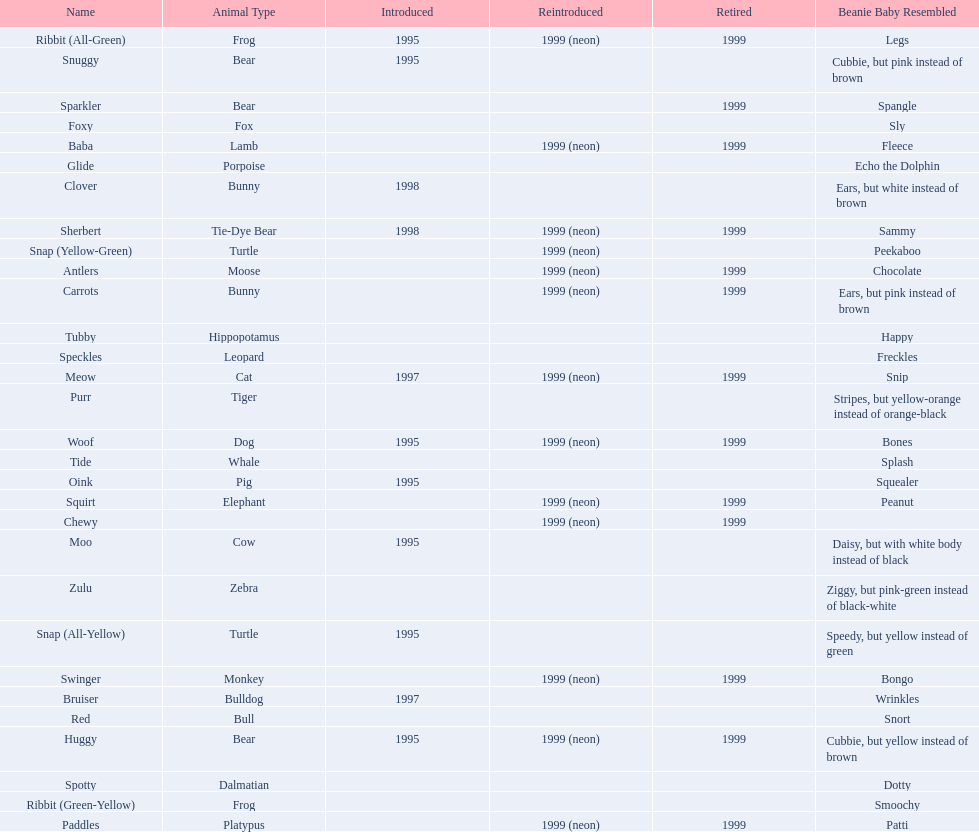Parse the full table. {'header': ['Name', 'Animal Type', 'Introduced', 'Reintroduced', 'Retired', 'Beanie Baby Resembled'], 'rows': [['Ribbit (All-Green)', 'Frog', '1995', '1999 (neon)', '1999', 'Legs'], ['Snuggy', 'Bear', '1995', '', '', 'Cubbie, but pink instead of brown'], ['Sparkler', 'Bear', '', '', '1999', 'Spangle'], ['Foxy', 'Fox', '', '', '', 'Sly'], ['Baba', 'Lamb', '', '1999 (neon)', '1999', 'Fleece'], ['Glide', 'Porpoise', '', '', '', 'Echo the Dolphin'], ['Clover', 'Bunny', '1998', '', '', 'Ears, but white instead of brown'], ['Sherbert', 'Tie-Dye Bear', '1998', '1999 (neon)', '1999', 'Sammy'], ['Snap (Yellow-Green)', 'Turtle', '', '1999 (neon)', '', 'Peekaboo'], ['Antlers', 'Moose', '', '1999 (neon)', '1999', 'Chocolate'], ['Carrots', 'Bunny', '', '1999 (neon)', '1999', 'Ears, but pink instead of brown'], ['Tubby', 'Hippopotamus', '', '', '', 'Happy'], ['Speckles', 'Leopard', '', '', '', 'Freckles'], ['Meow', 'Cat', '1997', '1999 (neon)', '1999', 'Snip'], ['Purr', 'Tiger', '', '', '', 'Stripes, but yellow-orange instead of orange-black'], ['Woof', 'Dog', '1995', '1999 (neon)', '1999', 'Bones'], ['Tide', 'Whale', '', '', '', 'Splash'], ['Oink', 'Pig', '1995', '', '', 'Squealer'], ['Squirt', 'Elephant', '', '1999 (neon)', '1999', 'Peanut'], ['Chewy', '', '', '1999 (neon)', '1999', ''], ['Moo', 'Cow', '1995', '', '', 'Daisy, but with white body instead of black'], ['Zulu', 'Zebra', '', '', '', 'Ziggy, but pink-green instead of black-white'], ['Snap (All-Yellow)', 'Turtle', '1995', '', '', 'Speedy, but yellow instead of green'], ['Swinger', 'Monkey', '', '1999 (neon)', '1999', 'Bongo'], ['Bruiser', 'Bulldog', '1997', '', '', 'Wrinkles'], ['Red', 'Bull', '', '', '', 'Snort'], ['Huggy', 'Bear', '1995', '1999 (neon)', '1999', 'Cubbie, but yellow instead of brown'], ['Spotty', 'Dalmatian', '', '', '', 'Dotty'], ['Ribbit (Green-Yellow)', 'Frog', '', '', '', 'Smoochy'], ['Paddles', 'Platypus', '', '1999 (neon)', '1999', 'Patti']]} Which of the listed pillow pals lack information in at least 3 categories? Chewy, Foxy, Glide, Purr, Red, Ribbit (Green-Yellow), Speckles, Spotty, Tide, Tubby, Zulu. Of those, which one lacks information in the animal type category? Chewy. 